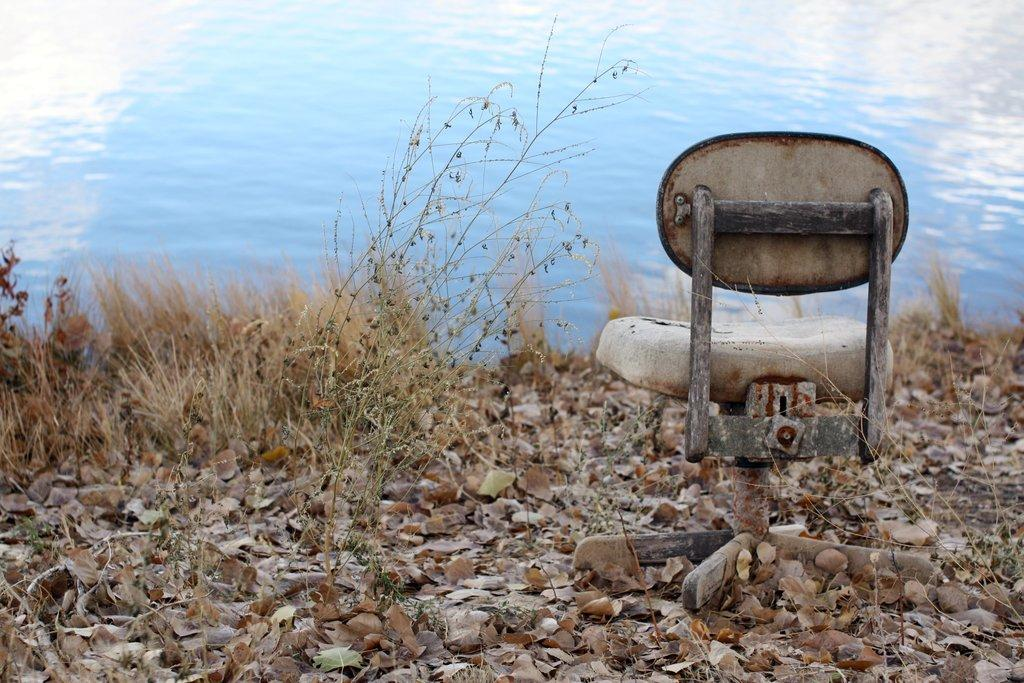What type of furniture can be seen in the image? There is a chair in the image. What type of vegetation is present in the image? There are plants and leaves visible in the image. What is the ground made of in the image? Grass is visible at the bottom of the image. What else can be seen in the image besides the chair and plants? There is water in the image. Where is the school located in the image? There is no school present in the image. What type of tray is being used to hold the water in the image? There is no tray visible in the image; the water is not contained in a tray. 